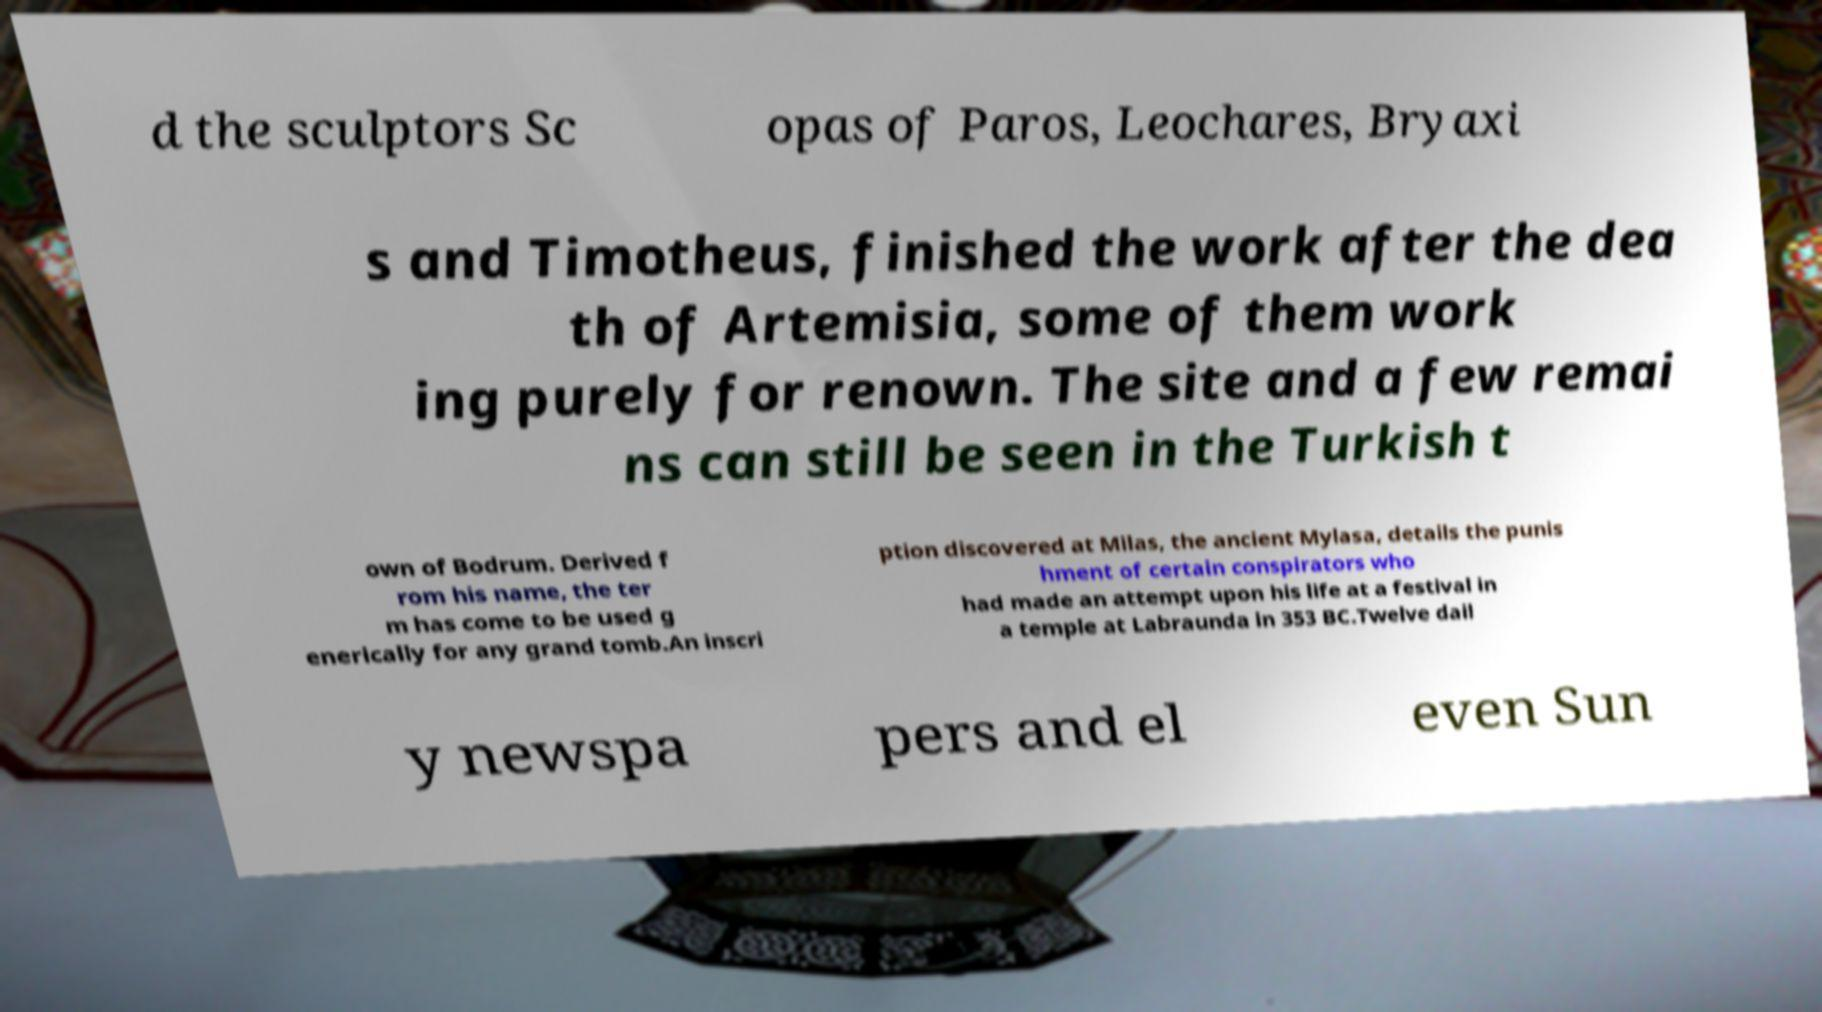For documentation purposes, I need the text within this image transcribed. Could you provide that? d the sculptors Sc opas of Paros, Leochares, Bryaxi s and Timotheus, finished the work after the dea th of Artemisia, some of them work ing purely for renown. The site and a few remai ns can still be seen in the Turkish t own of Bodrum. Derived f rom his name, the ter m has come to be used g enerically for any grand tomb.An inscri ption discovered at Milas, the ancient Mylasa, details the punis hment of certain conspirators who had made an attempt upon his life at a festival in a temple at Labraunda in 353 BC.Twelve dail y newspa pers and el even Sun 